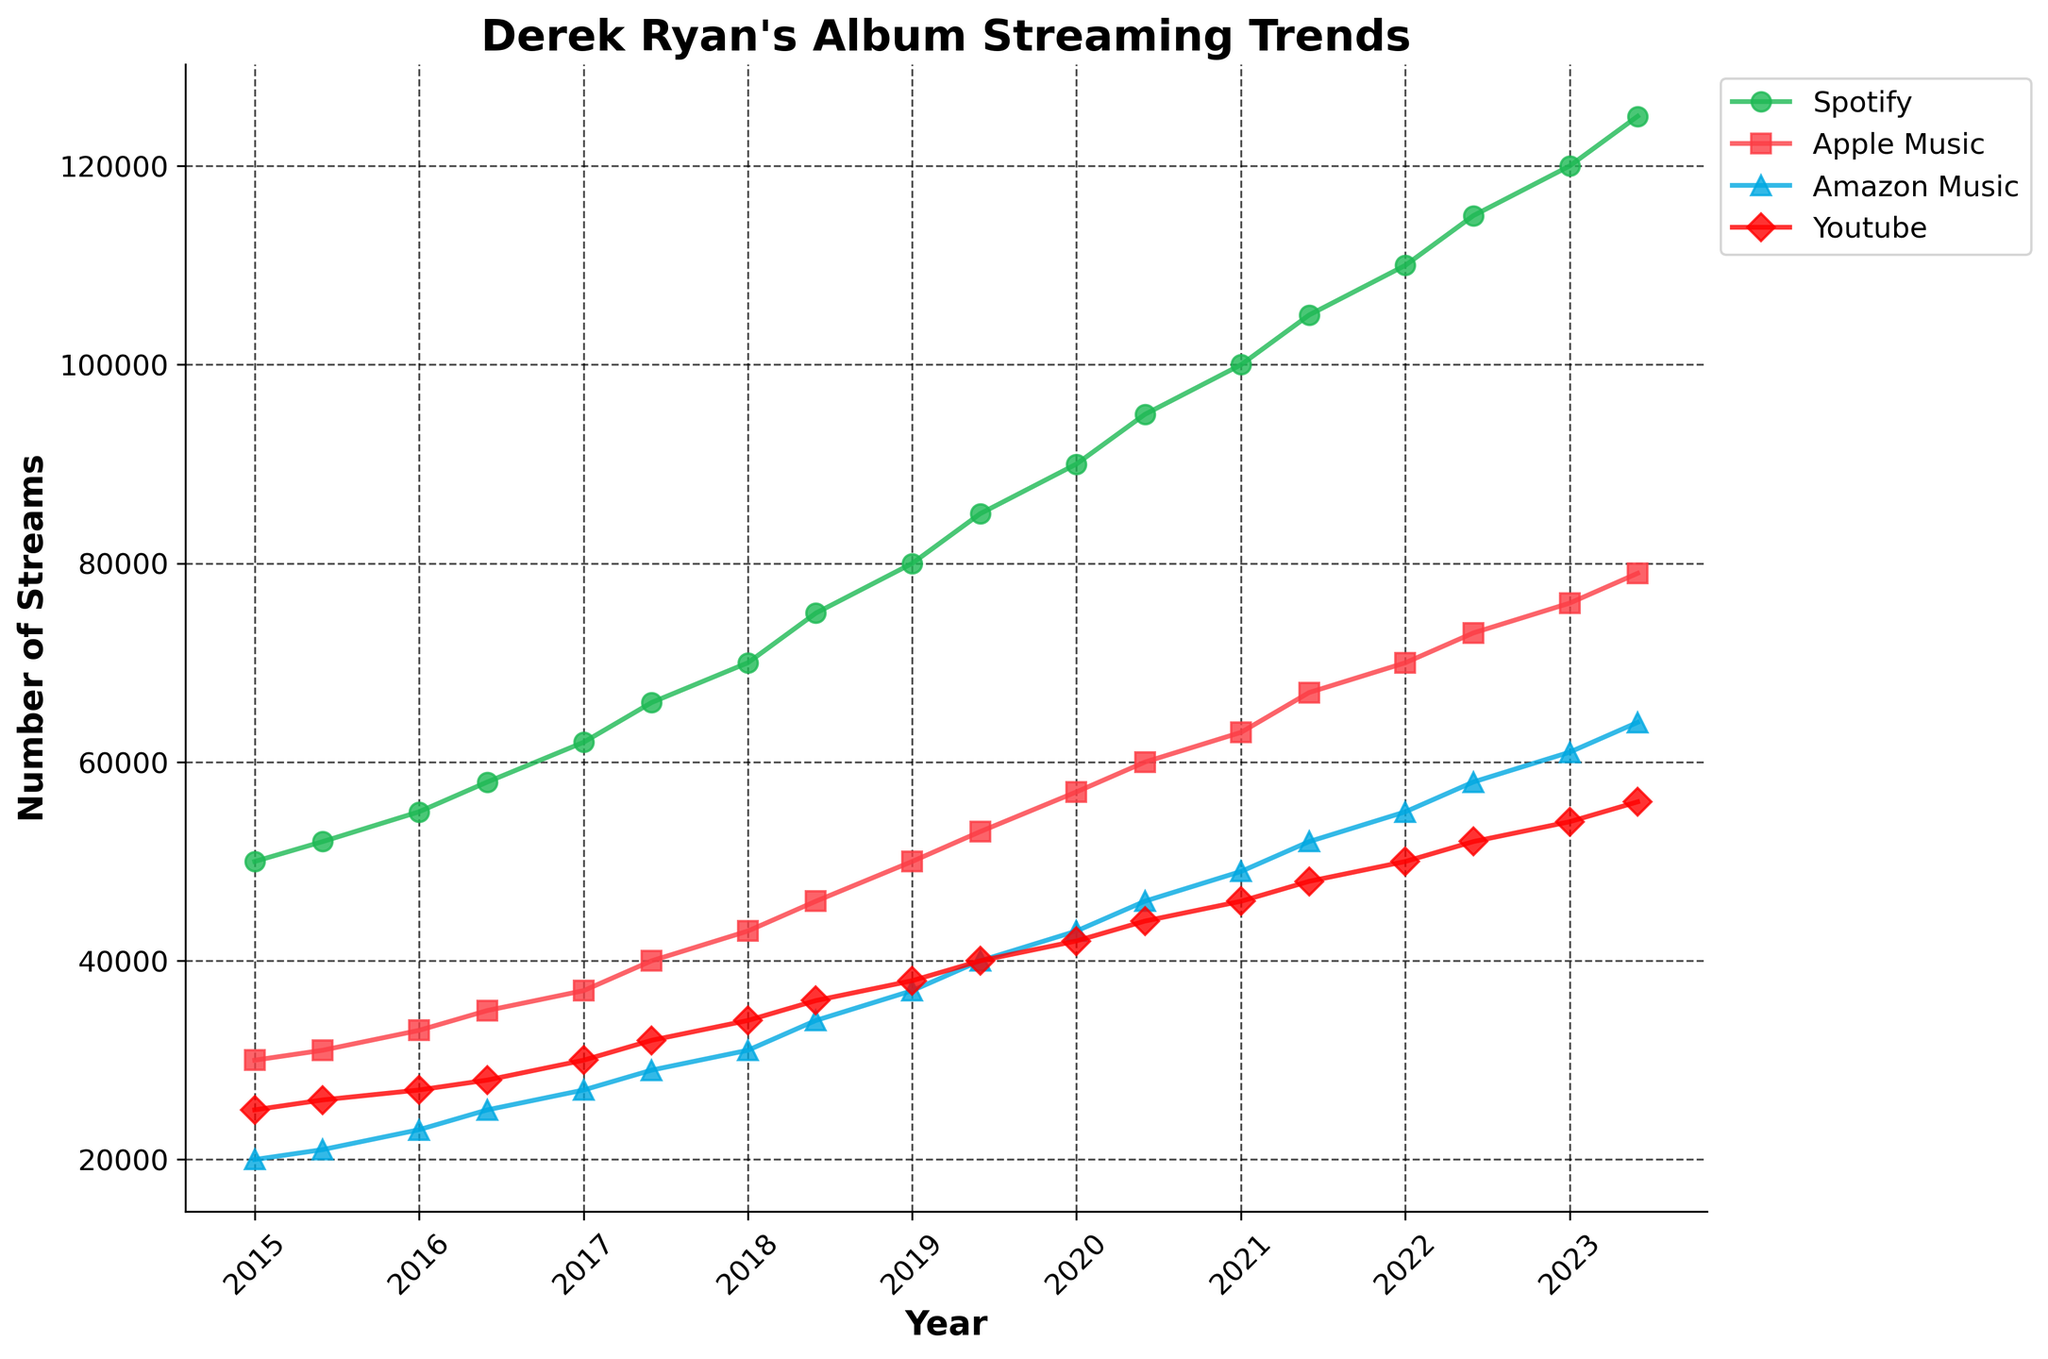What's the title of the plot? The title is usually located at the top of the plot. From the figure, it is written clearly.
Answer: Derek Ryan's Album Streaming Trends Which platform had the highest number of streams in January 2023? By looking at the plot for January 2023 (x-axis), the highest line/marker corresponds to the color and marker of the Spotify platform.
Answer: Spotify What is the general trend of streams on Amazon Music from 2015 to 2023? Observing the line representing Amazon Music, it shows a consistent increase throughout the years from 20,000 in 2015 to 64,000 in mid-2023.
Answer: Increasing How do the streaming numbers of Apple Music in 2022 compare with those in 2017? By comparing the data points for Apple Music in 2017 and 2022, 2017 had around 37,000-40,000 streams while 2022 had around 70,000-73,000 streams.
Answer: Apple Music streams doubled from 2017 to 2022 Which year shows the most significant single-year increase in Spotify streams? The year-to-year increase can be checked year by year. Between 2020 and 2021, the streams increased significantly from 90,000 to 100,000.
Answer: 2021 By what amount did YouTube streams increase from the beginning of 2019 to the middle of 2023? Check YouTube streams in January 2019 (38,000) and June 2023 (56,000). Subtracting the former from the latter gives the increase.
Answer: 18,000 In the first half of 2021, what's the difference in streaming numbers between Spotify and Amazon Music? Locate the data points for both Spotify (105,000) and Amazon Music (52,000) for the first half of 2021 and subtract the latter from the former to find the difference.
Answer: 53,000 Which platform shows the smallest increase in streaming numbers from 2015 to 2023? Calculate the difference for all platforms and compare. YouTube increased from 25,000 in 2015 to 56,000 in 2023 which is the smallest increase compared to others.
Answer: YouTube Are there any periods where no increase in streaming numbers is observed for any platform? By carefully studying the plot, every platform shows a consistent increase without any period of plateau.
Answer: No 